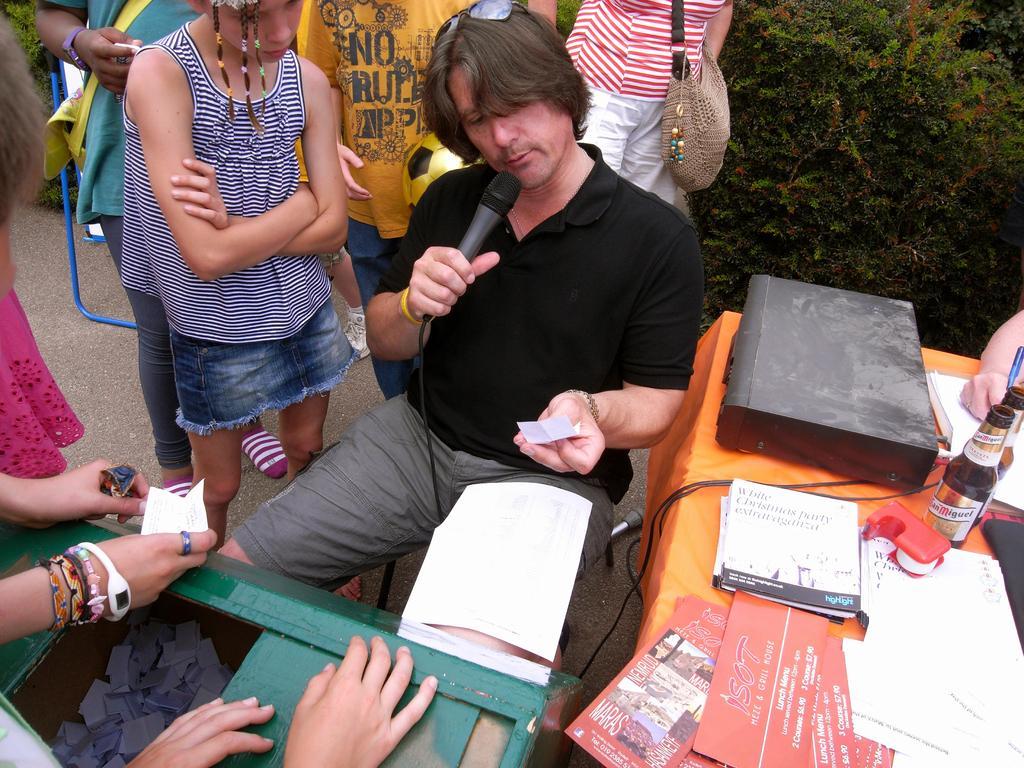In one or two sentences, can you explain what this image depicts? In this image at the right side there is a table and on top of it there are two bottles, books and papers. Beside the table there is a person sitting on the chair by holding the mike. Behind him there are few other people standing on the road. In front of them there is another table. On the backside there are plants. 